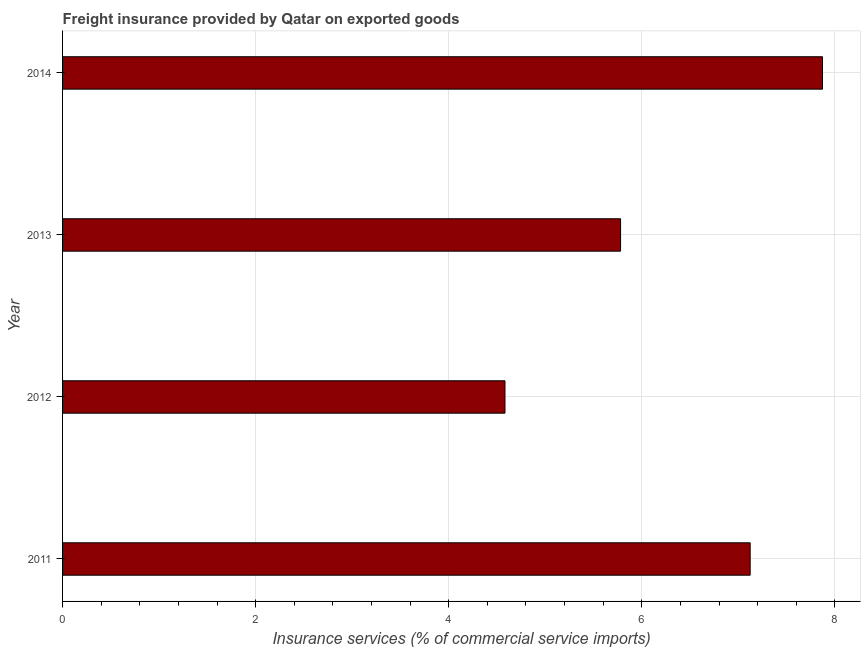Does the graph contain any zero values?
Your response must be concise. No. Does the graph contain grids?
Make the answer very short. Yes. What is the title of the graph?
Make the answer very short. Freight insurance provided by Qatar on exported goods . What is the label or title of the X-axis?
Ensure brevity in your answer.  Insurance services (% of commercial service imports). What is the freight insurance in 2011?
Your answer should be very brief. 7.12. Across all years, what is the maximum freight insurance?
Ensure brevity in your answer.  7.87. Across all years, what is the minimum freight insurance?
Your answer should be very brief. 4.58. In which year was the freight insurance maximum?
Make the answer very short. 2014. In which year was the freight insurance minimum?
Make the answer very short. 2012. What is the sum of the freight insurance?
Give a very brief answer. 25.36. What is the difference between the freight insurance in 2011 and 2012?
Your answer should be very brief. 2.54. What is the average freight insurance per year?
Your answer should be very brief. 6.34. What is the median freight insurance?
Keep it short and to the point. 6.45. What is the ratio of the freight insurance in 2012 to that in 2013?
Your answer should be very brief. 0.79. Is the freight insurance in 2012 less than that in 2014?
Provide a succinct answer. Yes. Is the difference between the freight insurance in 2013 and 2014 greater than the difference between any two years?
Your answer should be very brief. No. What is the difference between the highest and the second highest freight insurance?
Give a very brief answer. 0.75. What is the difference between the highest and the lowest freight insurance?
Provide a succinct answer. 3.29. How many years are there in the graph?
Offer a very short reply. 4. What is the difference between two consecutive major ticks on the X-axis?
Your response must be concise. 2. What is the Insurance services (% of commercial service imports) in 2011?
Your answer should be very brief. 7.12. What is the Insurance services (% of commercial service imports) of 2012?
Offer a very short reply. 4.58. What is the Insurance services (% of commercial service imports) of 2013?
Offer a terse response. 5.78. What is the Insurance services (% of commercial service imports) of 2014?
Offer a terse response. 7.87. What is the difference between the Insurance services (% of commercial service imports) in 2011 and 2012?
Give a very brief answer. 2.54. What is the difference between the Insurance services (% of commercial service imports) in 2011 and 2013?
Offer a terse response. 1.34. What is the difference between the Insurance services (% of commercial service imports) in 2011 and 2014?
Your answer should be very brief. -0.75. What is the difference between the Insurance services (% of commercial service imports) in 2012 and 2013?
Make the answer very short. -1.2. What is the difference between the Insurance services (% of commercial service imports) in 2012 and 2014?
Your response must be concise. -3.29. What is the difference between the Insurance services (% of commercial service imports) in 2013 and 2014?
Keep it short and to the point. -2.09. What is the ratio of the Insurance services (% of commercial service imports) in 2011 to that in 2012?
Ensure brevity in your answer.  1.55. What is the ratio of the Insurance services (% of commercial service imports) in 2011 to that in 2013?
Your answer should be compact. 1.23. What is the ratio of the Insurance services (% of commercial service imports) in 2011 to that in 2014?
Your response must be concise. 0.91. What is the ratio of the Insurance services (% of commercial service imports) in 2012 to that in 2013?
Your answer should be compact. 0.79. What is the ratio of the Insurance services (% of commercial service imports) in 2012 to that in 2014?
Your answer should be very brief. 0.58. What is the ratio of the Insurance services (% of commercial service imports) in 2013 to that in 2014?
Offer a very short reply. 0.73. 